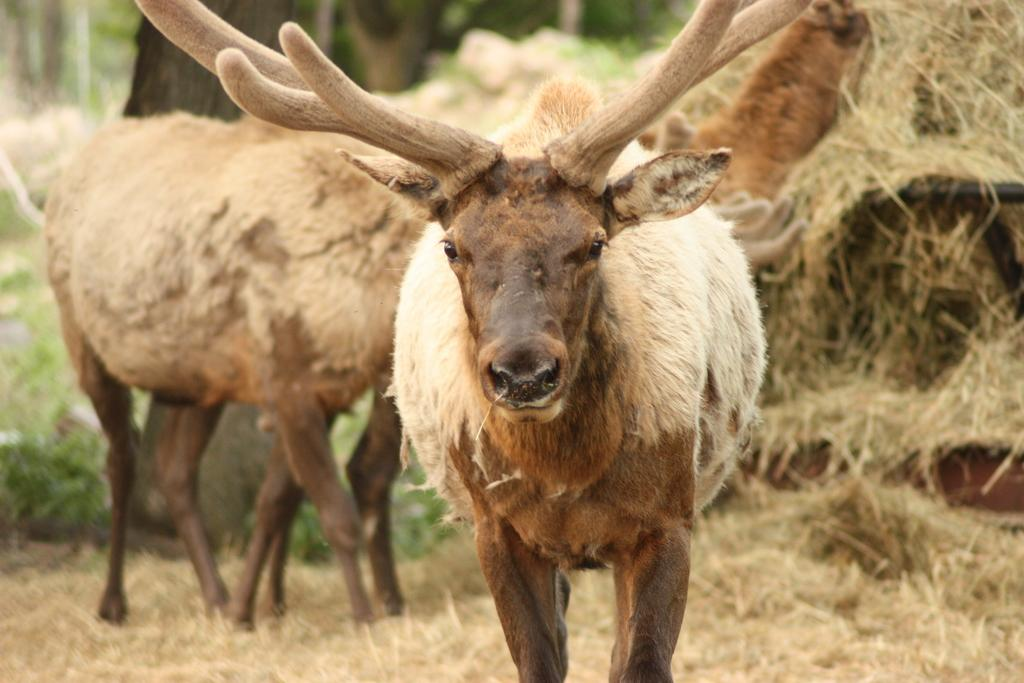What is the main subject in the center of the image? There are animals in the center of the image. What type of vegetation can be seen on the right side of the image? There is dry grass on the right side of the image. Can you describe the background of the image? The background of the image is blurry. What type of books can be seen in the cemetery in the image? There is no cemetery or books present in the image; it features animals and dry grass. 